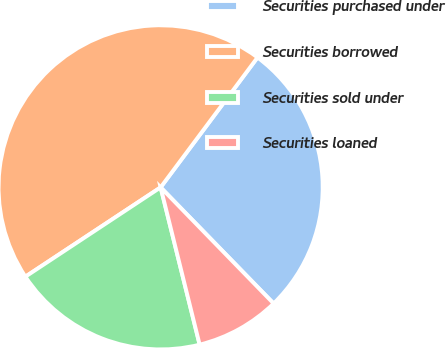<chart> <loc_0><loc_0><loc_500><loc_500><pie_chart><fcel>Securities purchased under<fcel>Securities borrowed<fcel>Securities sold under<fcel>Securities loaned<nl><fcel>27.52%<fcel>44.49%<fcel>19.58%<fcel>8.41%<nl></chart> 